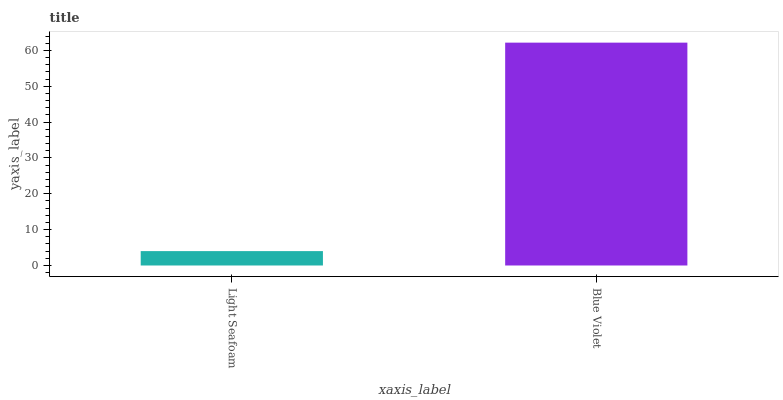Is Light Seafoam the minimum?
Answer yes or no. Yes. Is Blue Violet the maximum?
Answer yes or no. Yes. Is Blue Violet the minimum?
Answer yes or no. No. Is Blue Violet greater than Light Seafoam?
Answer yes or no. Yes. Is Light Seafoam less than Blue Violet?
Answer yes or no. Yes. Is Light Seafoam greater than Blue Violet?
Answer yes or no. No. Is Blue Violet less than Light Seafoam?
Answer yes or no. No. Is Blue Violet the high median?
Answer yes or no. Yes. Is Light Seafoam the low median?
Answer yes or no. Yes. Is Light Seafoam the high median?
Answer yes or no. No. Is Blue Violet the low median?
Answer yes or no. No. 